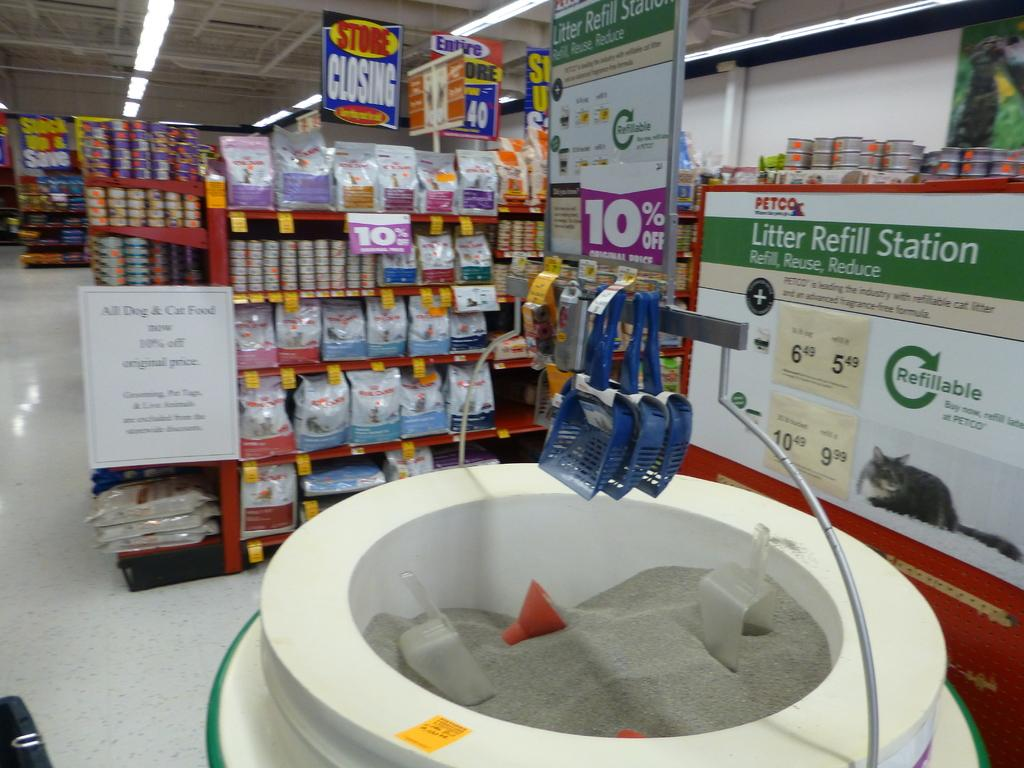<image>
Describe the image concisely. A litter Refill station located in a PETCO. 